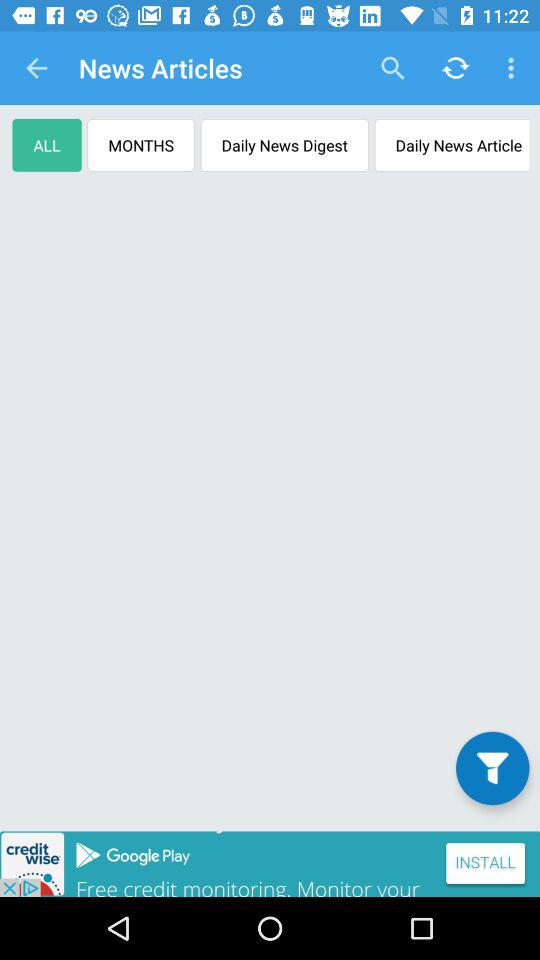Which tab am I on? You are on the "ALL" tab. 